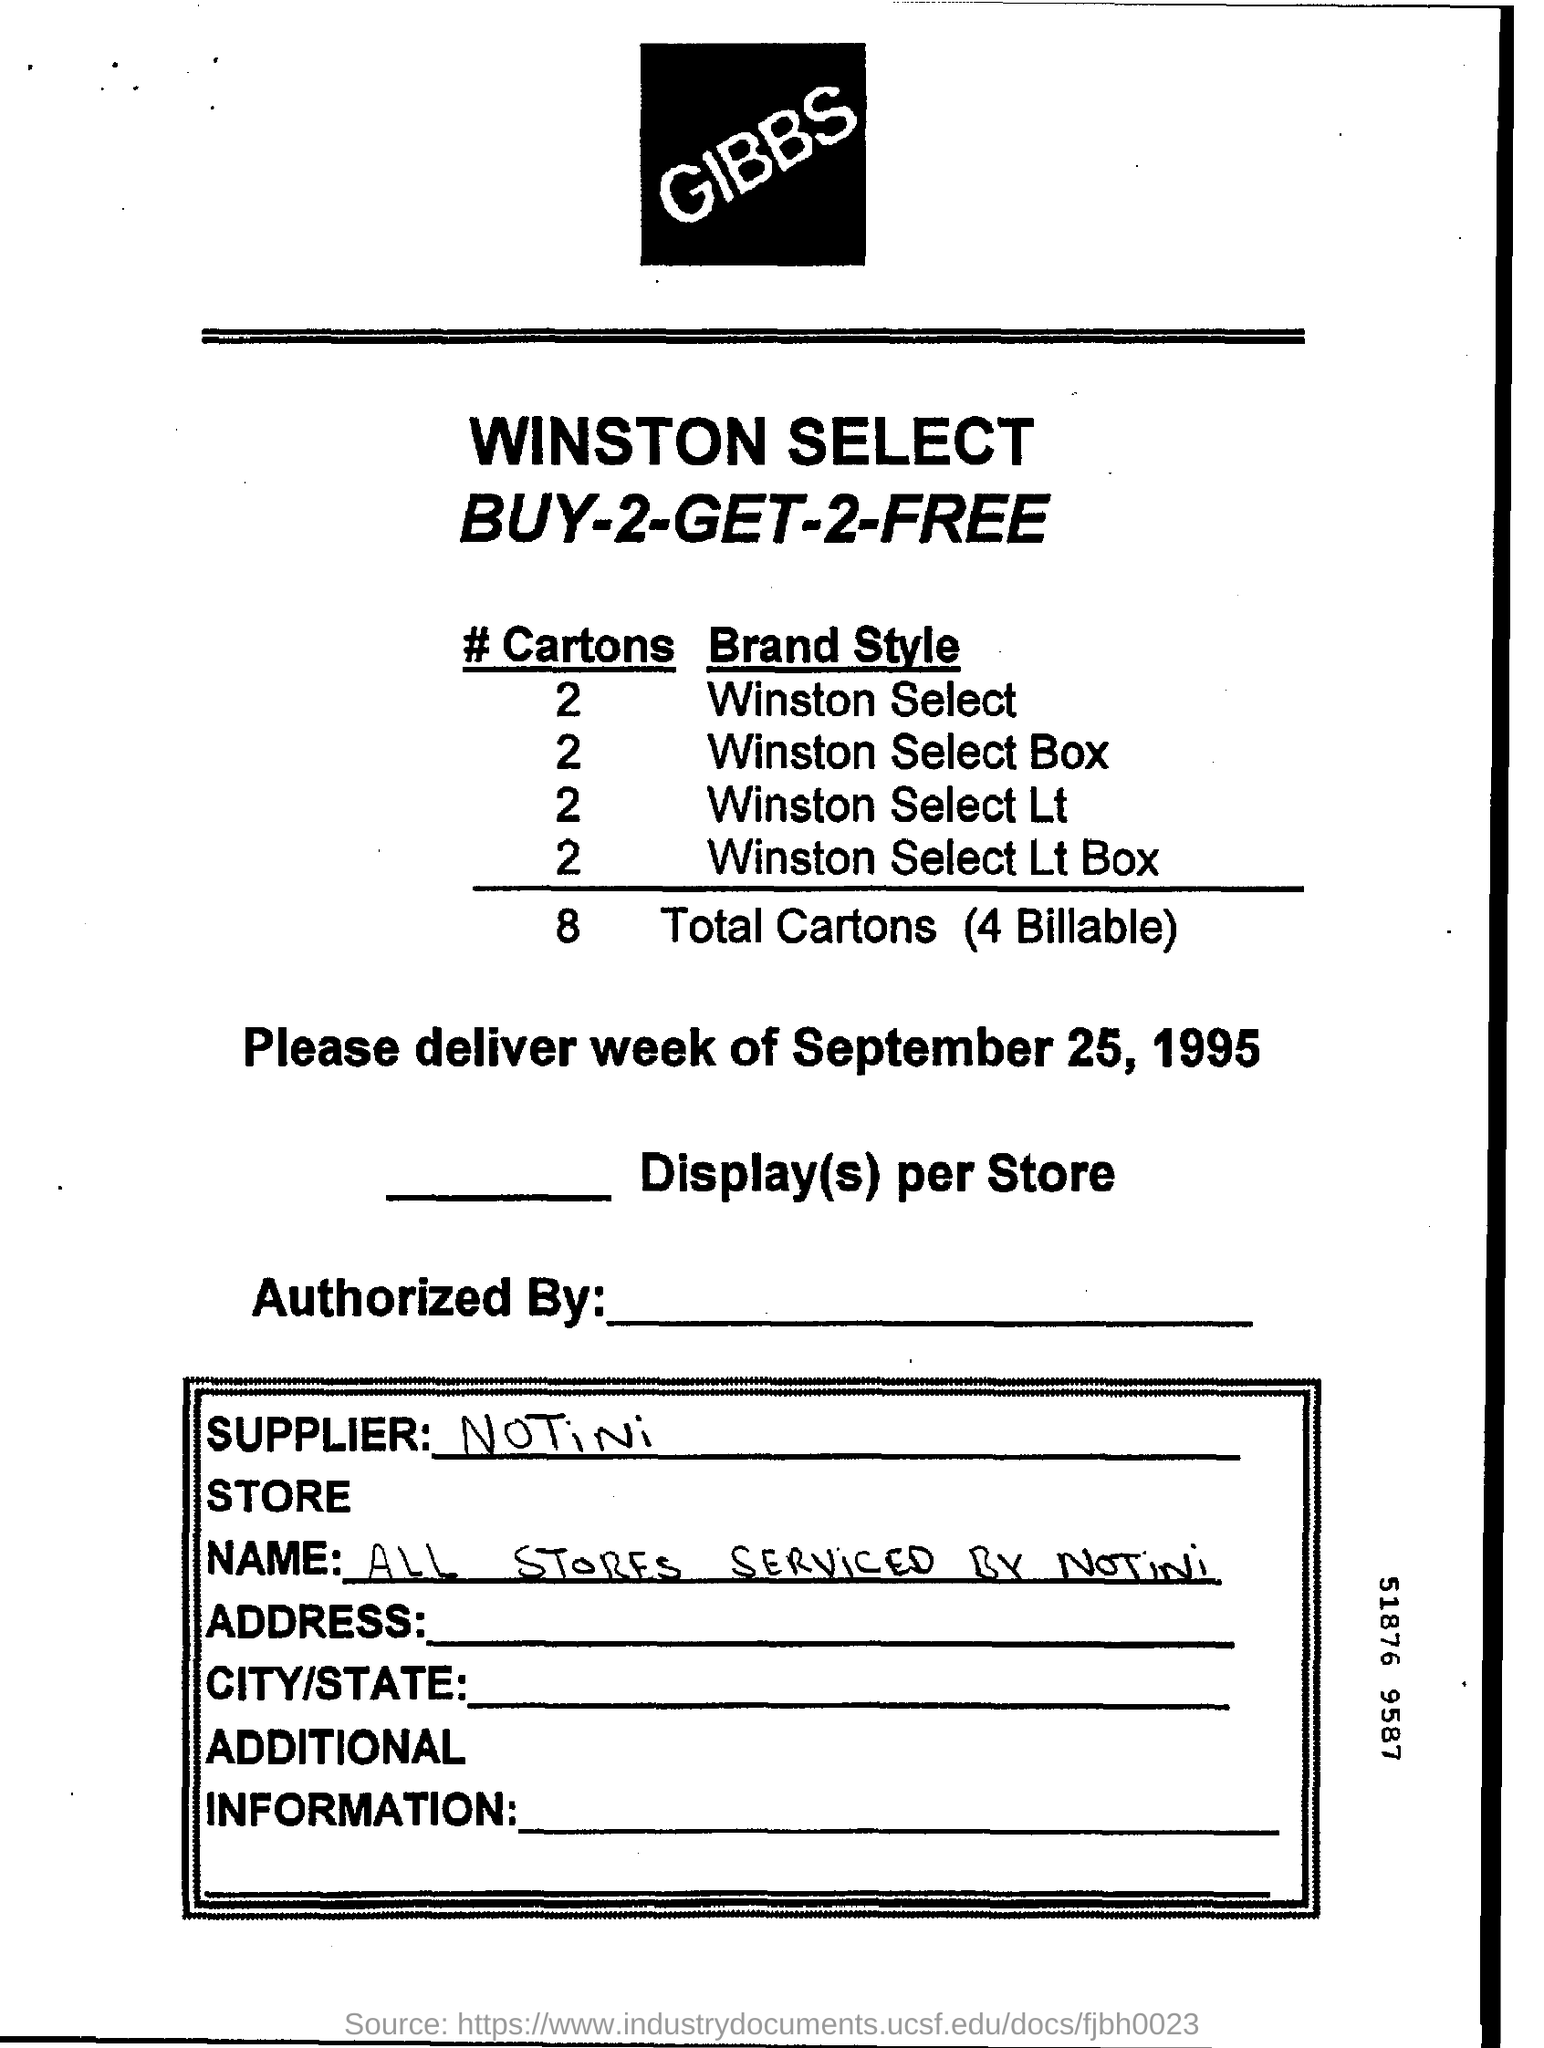What is the name of the supplier mentioned ?
Provide a succinct answer. Notini. What is the date mentioned  ?
Your answer should be very brief. September 25, 1995. How many no. of cartons are mentioned for winston select ?
Give a very brief answer. 2. How many no. of cartons are mentioned for winston select box ?
Provide a short and direct response. 2. What is the total no. of cartons mentioned ?
Your answer should be compact. 8. 